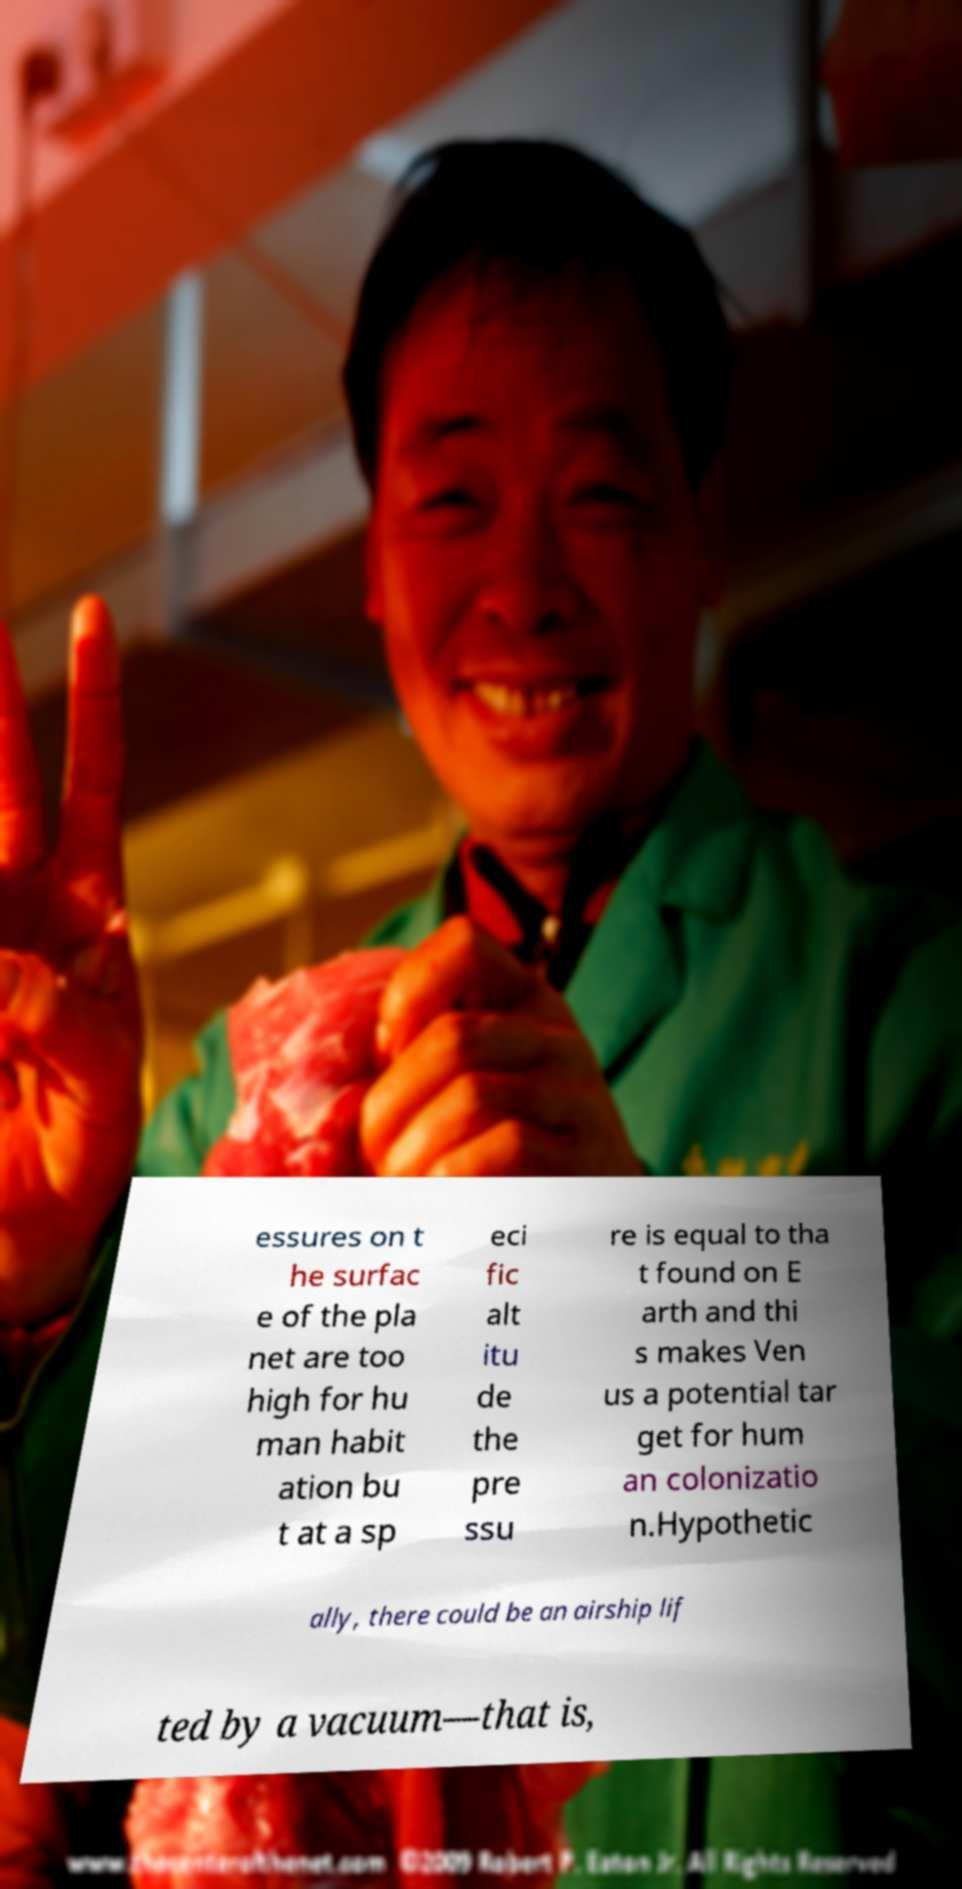Could you extract and type out the text from this image? essures on t he surfac e of the pla net are too high for hu man habit ation bu t at a sp eci fic alt itu de the pre ssu re is equal to tha t found on E arth and thi s makes Ven us a potential tar get for hum an colonizatio n.Hypothetic ally, there could be an airship lif ted by a vacuum—that is, 